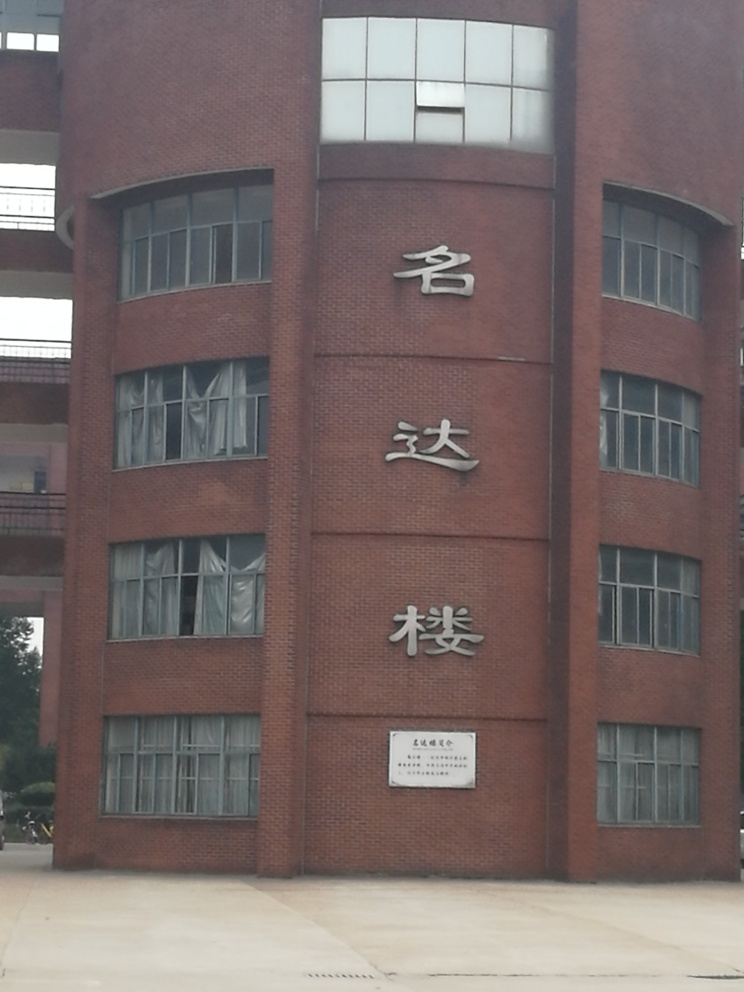How does the weather or lighting conditions seem to affect the appearance of the building? The overcast sky and the absence of strong shadows indicate that the photo was taken on a cloudy day or when the sun was not directly shining on the building. This lighting condition has resulted in a flat, even light across the façade, which can suppress textural details and contribute to a less vibrant appearance of the building's red brick exterior. 